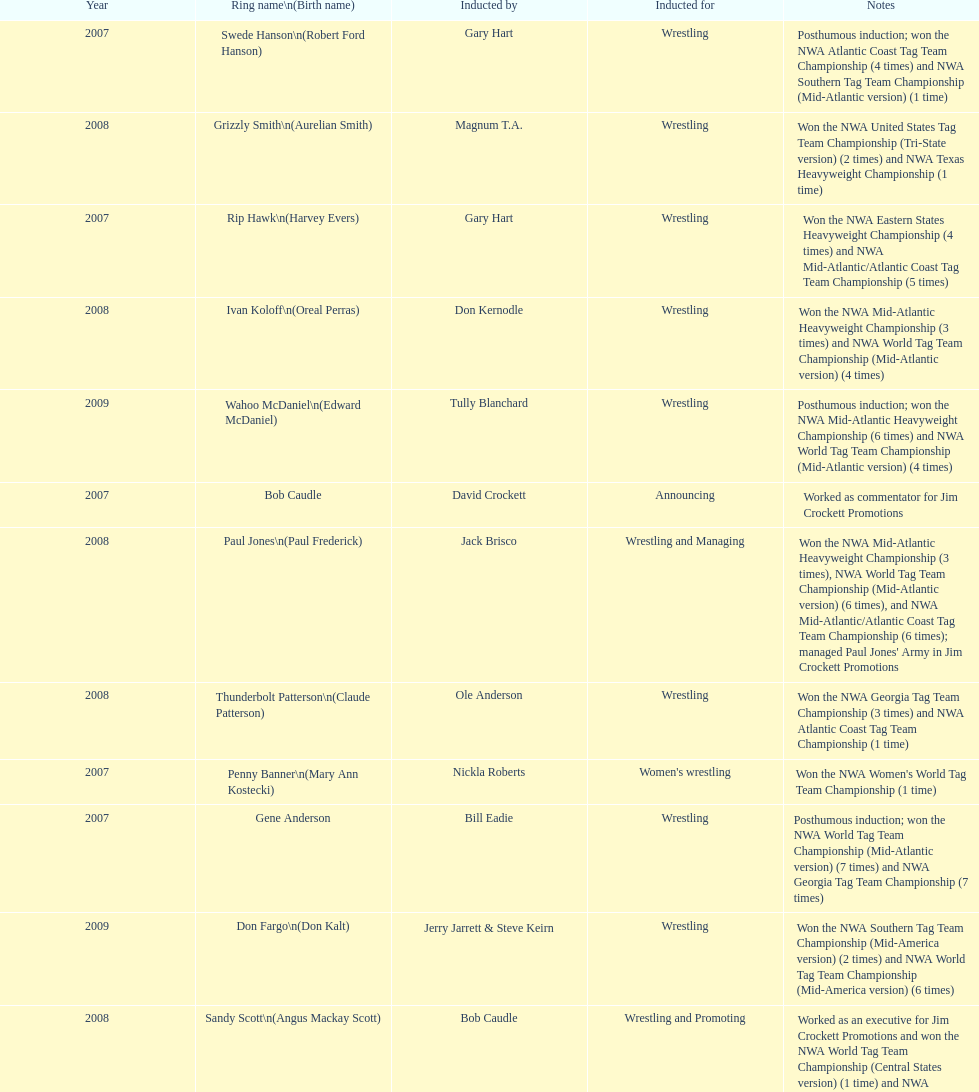Whose authentic name is dale hey, grizzly smith, or buddy roberts? Buddy Roberts. 